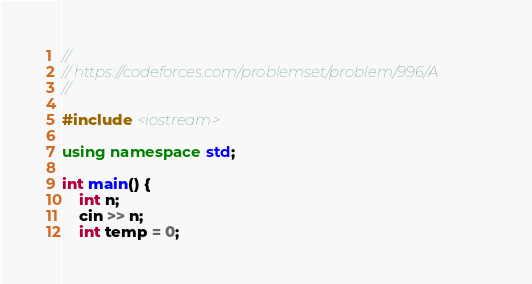<code> <loc_0><loc_0><loc_500><loc_500><_C++_>//
// https://codeforces.com/problemset/problem/996/A
//

#include <iostream>

using namespace std;

int main() {
    int n;
    cin >> n;
    int temp = 0;</code> 